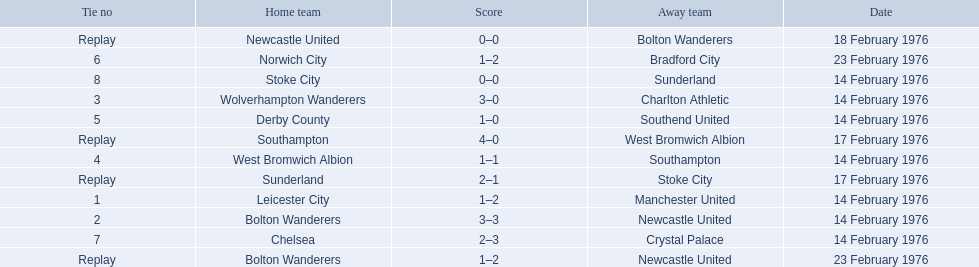Who were all of the teams? Leicester City, Manchester United, Bolton Wanderers, Newcastle United, Newcastle United, Bolton Wanderers, Bolton Wanderers, Newcastle United, Wolverhampton Wanderers, Charlton Athletic, West Bromwich Albion, Southampton, Southampton, West Bromwich Albion, Derby County, Southend United, Norwich City, Bradford City, Chelsea, Crystal Palace, Stoke City, Sunderland, Sunderland, Stoke City. And what were their scores? 1–2, 3–3, 0–0, 1–2, 3–0, 1–1, 4–0, 1–0, 1–2, 2–3, 0–0, 2–1. Between manchester and wolverhampton, who scored more? Wolverhampton Wanderers. 